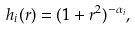Convert formula to latex. <formula><loc_0><loc_0><loc_500><loc_500>h _ { i } ( r ) = ( 1 + r ^ { 2 } ) ^ { - \alpha _ { i } } ,</formula> 